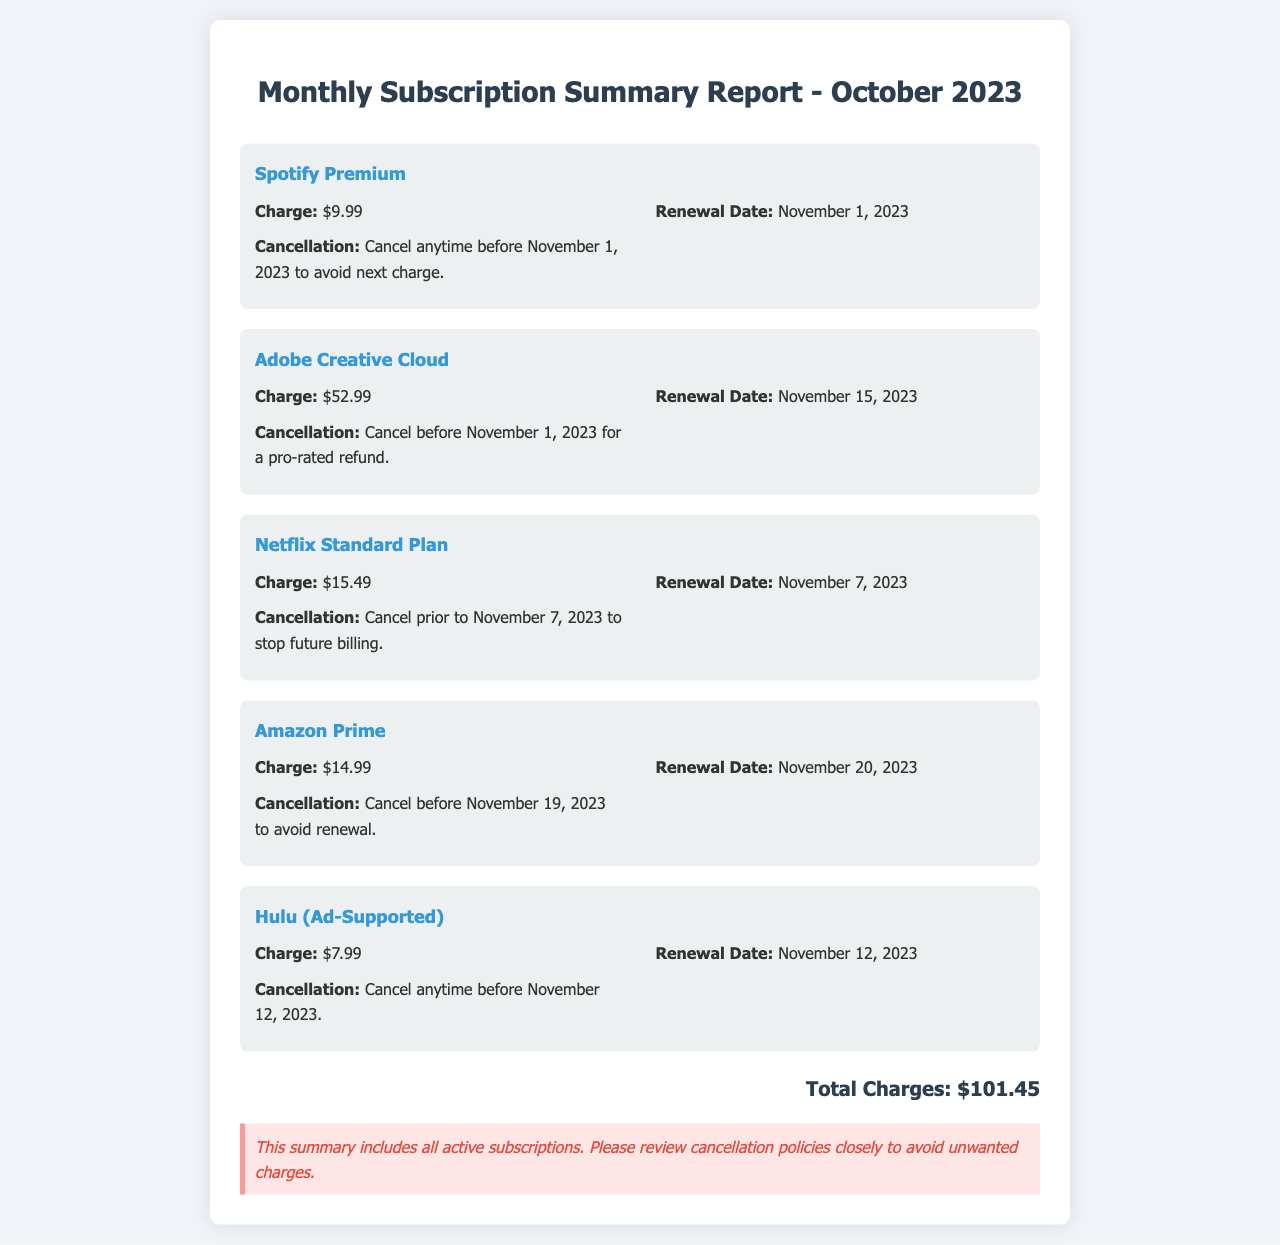What is the total charge for all subscriptions? The total charge is calculated by summing up all individual charges listed in the document, which totals $101.45.
Answer: $101.45 When is the renewal date for Hulu? The renewal date for Hulu is specified in the service details of the document as November 12, 2023.
Answer: November 12, 2023 What is the charge for Adobe Creative Cloud? The document states the charge for Adobe Creative Cloud under service details as $52.99.
Answer: $52.99 How can I cancel Netflix to avoid being charged? The document includes the cancellation policy for Netflix, which states to cancel prior to November 7, 2023, to stop future billing.
Answer: Cancel prior to November 7, 2023 What is the cancellation policy for Amazon Prime? The cancellation policy mentioned for Amazon Prime is to cancel before November 19, 2023, to avoid renewal.
Answer: Cancel before November 19, 2023 Which service has the next renewal date after Spotify? By reviewing the renewal dates, the service with the next renewal date after Spotify's November 1, 2023, is Netflix on November 7, 2023.
Answer: Netflix What is the background color of the report? The background color of the report as described in the style section is a light shade of grey denoted by the hexadecimal color #f0f4f8.
Answer: #f0f4f8 